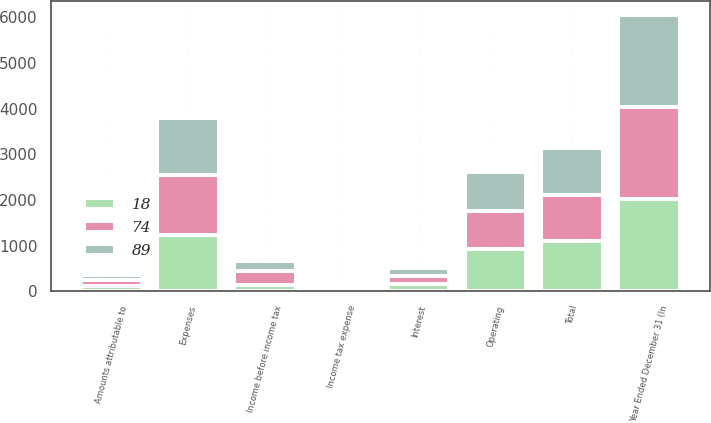<chart> <loc_0><loc_0><loc_500><loc_500><stacked_bar_chart><ecel><fcel>Year Ended December 31 (In<fcel>Expenses<fcel>Operating<fcel>Interest<fcel>Total<fcel>Income before income tax<fcel>Income tax expense<fcel>Amounts attributable to<nl><fcel>74<fcel>2016<fcel>1316<fcel>835<fcel>183<fcel>1018<fcel>298<fcel>61<fcel>148<nl><fcel>89<fcel>2015<fcel>1254<fcel>851<fcel>176<fcel>1027<fcel>227<fcel>46<fcel>107<nl><fcel>18<fcel>2014<fcel>1236<fcel>931<fcel>165<fcel>1096<fcel>140<fcel>11<fcel>111<nl></chart> 